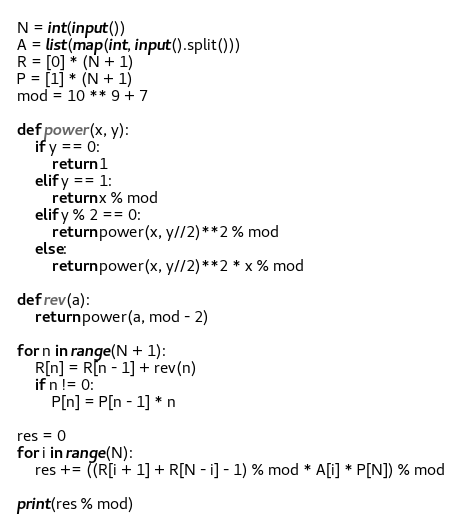Convert code to text. <code><loc_0><loc_0><loc_500><loc_500><_Python_>N = int(input())
A = list(map(int, input().split()))
R = [0] * (N + 1)
P = [1] * (N + 1)
mod = 10 ** 9 + 7

def power(x, y):
    if y == 0:
        return 1
    elif y == 1: 
        return x % mod
    elif y % 2 == 0: 
        return power(x, y//2)**2 % mod
    else: 
        return power(x, y//2)**2 * x % mod

def rev(a):
    return power(a, mod - 2)
    
for n in range(N + 1):
    R[n] = R[n - 1] + rev(n)
    if n != 0:
        P[n] = P[n - 1] * n

res = 0
for i in range(N):
    res += ((R[i + 1] + R[N - i] - 1) % mod * A[i] * P[N]) % mod

print(res % mod)
</code> 